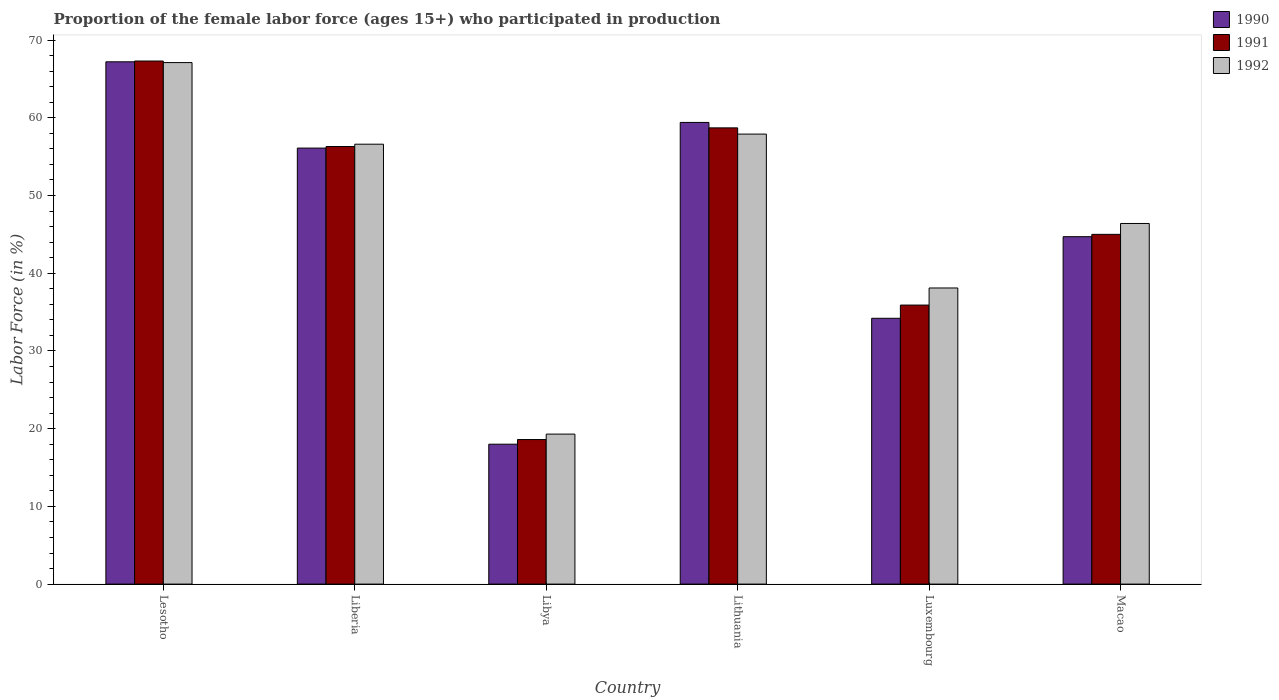How many different coloured bars are there?
Offer a terse response. 3. How many bars are there on the 1st tick from the left?
Your response must be concise. 3. How many bars are there on the 3rd tick from the right?
Your answer should be compact. 3. What is the label of the 5th group of bars from the left?
Your response must be concise. Luxembourg. In how many cases, is the number of bars for a given country not equal to the number of legend labels?
Your response must be concise. 0. What is the proportion of the female labor force who participated in production in 1992 in Liberia?
Provide a succinct answer. 56.6. Across all countries, what is the maximum proportion of the female labor force who participated in production in 1990?
Your response must be concise. 67.2. Across all countries, what is the minimum proportion of the female labor force who participated in production in 1991?
Your answer should be very brief. 18.6. In which country was the proportion of the female labor force who participated in production in 1991 maximum?
Make the answer very short. Lesotho. In which country was the proportion of the female labor force who participated in production in 1992 minimum?
Your answer should be very brief. Libya. What is the total proportion of the female labor force who participated in production in 1990 in the graph?
Your answer should be very brief. 279.6. What is the difference between the proportion of the female labor force who participated in production in 1991 in Liberia and that in Macao?
Give a very brief answer. 11.3. What is the difference between the proportion of the female labor force who participated in production in 1992 in Lithuania and the proportion of the female labor force who participated in production in 1991 in Lesotho?
Offer a very short reply. -9.4. What is the average proportion of the female labor force who participated in production in 1990 per country?
Provide a succinct answer. 46.6. What is the difference between the proportion of the female labor force who participated in production of/in 1991 and proportion of the female labor force who participated in production of/in 1992 in Lesotho?
Your answer should be very brief. 0.2. What is the ratio of the proportion of the female labor force who participated in production in 1991 in Liberia to that in Macao?
Your response must be concise. 1.25. What is the difference between the highest and the second highest proportion of the female labor force who participated in production in 1991?
Ensure brevity in your answer.  -2.4. What is the difference between the highest and the lowest proportion of the female labor force who participated in production in 1990?
Your answer should be compact. 49.2. What does the 1st bar from the right in Lithuania represents?
Provide a short and direct response. 1992. How many bars are there?
Provide a short and direct response. 18. What is the difference between two consecutive major ticks on the Y-axis?
Make the answer very short. 10. Are the values on the major ticks of Y-axis written in scientific E-notation?
Offer a very short reply. No. Does the graph contain grids?
Offer a very short reply. No. Where does the legend appear in the graph?
Ensure brevity in your answer.  Top right. How many legend labels are there?
Ensure brevity in your answer.  3. How are the legend labels stacked?
Make the answer very short. Vertical. What is the title of the graph?
Provide a short and direct response. Proportion of the female labor force (ages 15+) who participated in production. Does "1995" appear as one of the legend labels in the graph?
Offer a very short reply. No. What is the label or title of the X-axis?
Provide a succinct answer. Country. What is the label or title of the Y-axis?
Provide a succinct answer. Labor Force (in %). What is the Labor Force (in %) in 1990 in Lesotho?
Provide a short and direct response. 67.2. What is the Labor Force (in %) in 1991 in Lesotho?
Offer a terse response. 67.3. What is the Labor Force (in %) in 1992 in Lesotho?
Give a very brief answer. 67.1. What is the Labor Force (in %) of 1990 in Liberia?
Provide a succinct answer. 56.1. What is the Labor Force (in %) of 1991 in Liberia?
Provide a succinct answer. 56.3. What is the Labor Force (in %) in 1992 in Liberia?
Ensure brevity in your answer.  56.6. What is the Labor Force (in %) in 1991 in Libya?
Your response must be concise. 18.6. What is the Labor Force (in %) in 1992 in Libya?
Give a very brief answer. 19.3. What is the Labor Force (in %) of 1990 in Lithuania?
Keep it short and to the point. 59.4. What is the Labor Force (in %) of 1991 in Lithuania?
Ensure brevity in your answer.  58.7. What is the Labor Force (in %) of 1992 in Lithuania?
Offer a terse response. 57.9. What is the Labor Force (in %) of 1990 in Luxembourg?
Offer a very short reply. 34.2. What is the Labor Force (in %) in 1991 in Luxembourg?
Make the answer very short. 35.9. What is the Labor Force (in %) of 1992 in Luxembourg?
Your response must be concise. 38.1. What is the Labor Force (in %) of 1990 in Macao?
Offer a very short reply. 44.7. What is the Labor Force (in %) of 1992 in Macao?
Your answer should be compact. 46.4. Across all countries, what is the maximum Labor Force (in %) of 1990?
Provide a succinct answer. 67.2. Across all countries, what is the maximum Labor Force (in %) in 1991?
Your answer should be very brief. 67.3. Across all countries, what is the maximum Labor Force (in %) of 1992?
Make the answer very short. 67.1. Across all countries, what is the minimum Labor Force (in %) of 1991?
Provide a short and direct response. 18.6. Across all countries, what is the minimum Labor Force (in %) in 1992?
Provide a short and direct response. 19.3. What is the total Labor Force (in %) in 1990 in the graph?
Your answer should be compact. 279.6. What is the total Labor Force (in %) of 1991 in the graph?
Your response must be concise. 281.8. What is the total Labor Force (in %) of 1992 in the graph?
Provide a succinct answer. 285.4. What is the difference between the Labor Force (in %) in 1990 in Lesotho and that in Liberia?
Your response must be concise. 11.1. What is the difference between the Labor Force (in %) of 1991 in Lesotho and that in Liberia?
Your answer should be compact. 11. What is the difference between the Labor Force (in %) of 1992 in Lesotho and that in Liberia?
Offer a very short reply. 10.5. What is the difference between the Labor Force (in %) of 1990 in Lesotho and that in Libya?
Your response must be concise. 49.2. What is the difference between the Labor Force (in %) in 1991 in Lesotho and that in Libya?
Your answer should be very brief. 48.7. What is the difference between the Labor Force (in %) in 1992 in Lesotho and that in Libya?
Keep it short and to the point. 47.8. What is the difference between the Labor Force (in %) of 1992 in Lesotho and that in Lithuania?
Your answer should be compact. 9.2. What is the difference between the Labor Force (in %) of 1990 in Lesotho and that in Luxembourg?
Keep it short and to the point. 33. What is the difference between the Labor Force (in %) of 1991 in Lesotho and that in Luxembourg?
Give a very brief answer. 31.4. What is the difference between the Labor Force (in %) in 1991 in Lesotho and that in Macao?
Provide a short and direct response. 22.3. What is the difference between the Labor Force (in %) in 1992 in Lesotho and that in Macao?
Provide a succinct answer. 20.7. What is the difference between the Labor Force (in %) of 1990 in Liberia and that in Libya?
Ensure brevity in your answer.  38.1. What is the difference between the Labor Force (in %) of 1991 in Liberia and that in Libya?
Ensure brevity in your answer.  37.7. What is the difference between the Labor Force (in %) in 1992 in Liberia and that in Libya?
Provide a succinct answer. 37.3. What is the difference between the Labor Force (in %) of 1990 in Liberia and that in Luxembourg?
Your answer should be very brief. 21.9. What is the difference between the Labor Force (in %) of 1991 in Liberia and that in Luxembourg?
Provide a short and direct response. 20.4. What is the difference between the Labor Force (in %) of 1992 in Liberia and that in Luxembourg?
Your answer should be compact. 18.5. What is the difference between the Labor Force (in %) of 1991 in Liberia and that in Macao?
Give a very brief answer. 11.3. What is the difference between the Labor Force (in %) in 1992 in Liberia and that in Macao?
Give a very brief answer. 10.2. What is the difference between the Labor Force (in %) in 1990 in Libya and that in Lithuania?
Give a very brief answer. -41.4. What is the difference between the Labor Force (in %) of 1991 in Libya and that in Lithuania?
Ensure brevity in your answer.  -40.1. What is the difference between the Labor Force (in %) in 1992 in Libya and that in Lithuania?
Your answer should be compact. -38.6. What is the difference between the Labor Force (in %) in 1990 in Libya and that in Luxembourg?
Keep it short and to the point. -16.2. What is the difference between the Labor Force (in %) in 1991 in Libya and that in Luxembourg?
Offer a terse response. -17.3. What is the difference between the Labor Force (in %) in 1992 in Libya and that in Luxembourg?
Provide a short and direct response. -18.8. What is the difference between the Labor Force (in %) in 1990 in Libya and that in Macao?
Make the answer very short. -26.7. What is the difference between the Labor Force (in %) of 1991 in Libya and that in Macao?
Offer a terse response. -26.4. What is the difference between the Labor Force (in %) in 1992 in Libya and that in Macao?
Provide a short and direct response. -27.1. What is the difference between the Labor Force (in %) of 1990 in Lithuania and that in Luxembourg?
Your response must be concise. 25.2. What is the difference between the Labor Force (in %) in 1991 in Lithuania and that in Luxembourg?
Make the answer very short. 22.8. What is the difference between the Labor Force (in %) in 1992 in Lithuania and that in Luxembourg?
Keep it short and to the point. 19.8. What is the difference between the Labor Force (in %) in 1991 in Lithuania and that in Macao?
Provide a succinct answer. 13.7. What is the difference between the Labor Force (in %) in 1990 in Lesotho and the Labor Force (in %) in 1991 in Libya?
Provide a succinct answer. 48.6. What is the difference between the Labor Force (in %) in 1990 in Lesotho and the Labor Force (in %) in 1992 in Libya?
Your answer should be compact. 47.9. What is the difference between the Labor Force (in %) of 1990 in Lesotho and the Labor Force (in %) of 1991 in Lithuania?
Give a very brief answer. 8.5. What is the difference between the Labor Force (in %) in 1990 in Lesotho and the Labor Force (in %) in 1992 in Lithuania?
Keep it short and to the point. 9.3. What is the difference between the Labor Force (in %) of 1990 in Lesotho and the Labor Force (in %) of 1991 in Luxembourg?
Make the answer very short. 31.3. What is the difference between the Labor Force (in %) in 1990 in Lesotho and the Labor Force (in %) in 1992 in Luxembourg?
Provide a succinct answer. 29.1. What is the difference between the Labor Force (in %) of 1991 in Lesotho and the Labor Force (in %) of 1992 in Luxembourg?
Offer a very short reply. 29.2. What is the difference between the Labor Force (in %) of 1990 in Lesotho and the Labor Force (in %) of 1992 in Macao?
Give a very brief answer. 20.8. What is the difference between the Labor Force (in %) of 1991 in Lesotho and the Labor Force (in %) of 1992 in Macao?
Offer a very short reply. 20.9. What is the difference between the Labor Force (in %) in 1990 in Liberia and the Labor Force (in %) in 1991 in Libya?
Give a very brief answer. 37.5. What is the difference between the Labor Force (in %) in 1990 in Liberia and the Labor Force (in %) in 1992 in Libya?
Your answer should be compact. 36.8. What is the difference between the Labor Force (in %) of 1990 in Liberia and the Labor Force (in %) of 1991 in Lithuania?
Make the answer very short. -2.6. What is the difference between the Labor Force (in %) in 1990 in Liberia and the Labor Force (in %) in 1991 in Luxembourg?
Your answer should be very brief. 20.2. What is the difference between the Labor Force (in %) in 1991 in Liberia and the Labor Force (in %) in 1992 in Luxembourg?
Provide a short and direct response. 18.2. What is the difference between the Labor Force (in %) in 1990 in Liberia and the Labor Force (in %) in 1991 in Macao?
Make the answer very short. 11.1. What is the difference between the Labor Force (in %) of 1990 in Libya and the Labor Force (in %) of 1991 in Lithuania?
Offer a very short reply. -40.7. What is the difference between the Labor Force (in %) of 1990 in Libya and the Labor Force (in %) of 1992 in Lithuania?
Your answer should be compact. -39.9. What is the difference between the Labor Force (in %) in 1991 in Libya and the Labor Force (in %) in 1992 in Lithuania?
Make the answer very short. -39.3. What is the difference between the Labor Force (in %) in 1990 in Libya and the Labor Force (in %) in 1991 in Luxembourg?
Give a very brief answer. -17.9. What is the difference between the Labor Force (in %) in 1990 in Libya and the Labor Force (in %) in 1992 in Luxembourg?
Your response must be concise. -20.1. What is the difference between the Labor Force (in %) of 1991 in Libya and the Labor Force (in %) of 1992 in Luxembourg?
Your answer should be very brief. -19.5. What is the difference between the Labor Force (in %) of 1990 in Libya and the Labor Force (in %) of 1991 in Macao?
Provide a succinct answer. -27. What is the difference between the Labor Force (in %) in 1990 in Libya and the Labor Force (in %) in 1992 in Macao?
Provide a succinct answer. -28.4. What is the difference between the Labor Force (in %) of 1991 in Libya and the Labor Force (in %) of 1992 in Macao?
Your answer should be very brief. -27.8. What is the difference between the Labor Force (in %) in 1990 in Lithuania and the Labor Force (in %) in 1991 in Luxembourg?
Your answer should be very brief. 23.5. What is the difference between the Labor Force (in %) of 1990 in Lithuania and the Labor Force (in %) of 1992 in Luxembourg?
Offer a terse response. 21.3. What is the difference between the Labor Force (in %) of 1991 in Lithuania and the Labor Force (in %) of 1992 in Luxembourg?
Ensure brevity in your answer.  20.6. What is the difference between the Labor Force (in %) in 1990 in Lithuania and the Labor Force (in %) in 1991 in Macao?
Your response must be concise. 14.4. What is the difference between the Labor Force (in %) in 1990 in Luxembourg and the Labor Force (in %) in 1991 in Macao?
Ensure brevity in your answer.  -10.8. What is the difference between the Labor Force (in %) in 1990 in Luxembourg and the Labor Force (in %) in 1992 in Macao?
Offer a terse response. -12.2. What is the average Labor Force (in %) in 1990 per country?
Provide a short and direct response. 46.6. What is the average Labor Force (in %) in 1991 per country?
Your response must be concise. 46.97. What is the average Labor Force (in %) of 1992 per country?
Keep it short and to the point. 47.57. What is the difference between the Labor Force (in %) of 1990 and Labor Force (in %) of 1992 in Lesotho?
Offer a very short reply. 0.1. What is the difference between the Labor Force (in %) of 1990 and Labor Force (in %) of 1992 in Liberia?
Give a very brief answer. -0.5. What is the difference between the Labor Force (in %) in 1990 and Labor Force (in %) in 1992 in Libya?
Provide a succinct answer. -1.3. What is the difference between the Labor Force (in %) of 1990 and Labor Force (in %) of 1991 in Lithuania?
Offer a very short reply. 0.7. What is the difference between the Labor Force (in %) in 1991 and Labor Force (in %) in 1992 in Lithuania?
Provide a short and direct response. 0.8. What is the difference between the Labor Force (in %) in 1990 and Labor Force (in %) in 1991 in Luxembourg?
Make the answer very short. -1.7. What is the ratio of the Labor Force (in %) in 1990 in Lesotho to that in Liberia?
Offer a very short reply. 1.2. What is the ratio of the Labor Force (in %) of 1991 in Lesotho to that in Liberia?
Your answer should be compact. 1.2. What is the ratio of the Labor Force (in %) of 1992 in Lesotho to that in Liberia?
Offer a terse response. 1.19. What is the ratio of the Labor Force (in %) in 1990 in Lesotho to that in Libya?
Give a very brief answer. 3.73. What is the ratio of the Labor Force (in %) in 1991 in Lesotho to that in Libya?
Give a very brief answer. 3.62. What is the ratio of the Labor Force (in %) in 1992 in Lesotho to that in Libya?
Offer a very short reply. 3.48. What is the ratio of the Labor Force (in %) in 1990 in Lesotho to that in Lithuania?
Provide a succinct answer. 1.13. What is the ratio of the Labor Force (in %) of 1991 in Lesotho to that in Lithuania?
Your answer should be compact. 1.15. What is the ratio of the Labor Force (in %) in 1992 in Lesotho to that in Lithuania?
Your answer should be compact. 1.16. What is the ratio of the Labor Force (in %) of 1990 in Lesotho to that in Luxembourg?
Provide a succinct answer. 1.96. What is the ratio of the Labor Force (in %) in 1991 in Lesotho to that in Luxembourg?
Provide a short and direct response. 1.87. What is the ratio of the Labor Force (in %) in 1992 in Lesotho to that in Luxembourg?
Keep it short and to the point. 1.76. What is the ratio of the Labor Force (in %) of 1990 in Lesotho to that in Macao?
Provide a short and direct response. 1.5. What is the ratio of the Labor Force (in %) of 1991 in Lesotho to that in Macao?
Offer a very short reply. 1.5. What is the ratio of the Labor Force (in %) of 1992 in Lesotho to that in Macao?
Provide a short and direct response. 1.45. What is the ratio of the Labor Force (in %) in 1990 in Liberia to that in Libya?
Ensure brevity in your answer.  3.12. What is the ratio of the Labor Force (in %) in 1991 in Liberia to that in Libya?
Your answer should be very brief. 3.03. What is the ratio of the Labor Force (in %) in 1992 in Liberia to that in Libya?
Give a very brief answer. 2.93. What is the ratio of the Labor Force (in %) in 1990 in Liberia to that in Lithuania?
Give a very brief answer. 0.94. What is the ratio of the Labor Force (in %) in 1991 in Liberia to that in Lithuania?
Provide a short and direct response. 0.96. What is the ratio of the Labor Force (in %) in 1992 in Liberia to that in Lithuania?
Keep it short and to the point. 0.98. What is the ratio of the Labor Force (in %) of 1990 in Liberia to that in Luxembourg?
Offer a very short reply. 1.64. What is the ratio of the Labor Force (in %) of 1991 in Liberia to that in Luxembourg?
Give a very brief answer. 1.57. What is the ratio of the Labor Force (in %) in 1992 in Liberia to that in Luxembourg?
Give a very brief answer. 1.49. What is the ratio of the Labor Force (in %) in 1990 in Liberia to that in Macao?
Offer a very short reply. 1.25. What is the ratio of the Labor Force (in %) in 1991 in Liberia to that in Macao?
Ensure brevity in your answer.  1.25. What is the ratio of the Labor Force (in %) in 1992 in Liberia to that in Macao?
Provide a succinct answer. 1.22. What is the ratio of the Labor Force (in %) in 1990 in Libya to that in Lithuania?
Provide a short and direct response. 0.3. What is the ratio of the Labor Force (in %) of 1991 in Libya to that in Lithuania?
Your answer should be compact. 0.32. What is the ratio of the Labor Force (in %) of 1990 in Libya to that in Luxembourg?
Your answer should be very brief. 0.53. What is the ratio of the Labor Force (in %) of 1991 in Libya to that in Luxembourg?
Give a very brief answer. 0.52. What is the ratio of the Labor Force (in %) in 1992 in Libya to that in Luxembourg?
Give a very brief answer. 0.51. What is the ratio of the Labor Force (in %) in 1990 in Libya to that in Macao?
Your answer should be compact. 0.4. What is the ratio of the Labor Force (in %) in 1991 in Libya to that in Macao?
Offer a very short reply. 0.41. What is the ratio of the Labor Force (in %) of 1992 in Libya to that in Macao?
Give a very brief answer. 0.42. What is the ratio of the Labor Force (in %) in 1990 in Lithuania to that in Luxembourg?
Give a very brief answer. 1.74. What is the ratio of the Labor Force (in %) in 1991 in Lithuania to that in Luxembourg?
Keep it short and to the point. 1.64. What is the ratio of the Labor Force (in %) of 1992 in Lithuania to that in Luxembourg?
Your answer should be compact. 1.52. What is the ratio of the Labor Force (in %) in 1990 in Lithuania to that in Macao?
Your response must be concise. 1.33. What is the ratio of the Labor Force (in %) of 1991 in Lithuania to that in Macao?
Your answer should be compact. 1.3. What is the ratio of the Labor Force (in %) of 1992 in Lithuania to that in Macao?
Provide a short and direct response. 1.25. What is the ratio of the Labor Force (in %) of 1990 in Luxembourg to that in Macao?
Your response must be concise. 0.77. What is the ratio of the Labor Force (in %) of 1991 in Luxembourg to that in Macao?
Make the answer very short. 0.8. What is the ratio of the Labor Force (in %) in 1992 in Luxembourg to that in Macao?
Your answer should be compact. 0.82. What is the difference between the highest and the second highest Labor Force (in %) of 1991?
Ensure brevity in your answer.  8.6. What is the difference between the highest and the second highest Labor Force (in %) in 1992?
Offer a terse response. 9.2. What is the difference between the highest and the lowest Labor Force (in %) in 1990?
Keep it short and to the point. 49.2. What is the difference between the highest and the lowest Labor Force (in %) of 1991?
Give a very brief answer. 48.7. What is the difference between the highest and the lowest Labor Force (in %) in 1992?
Your answer should be very brief. 47.8. 